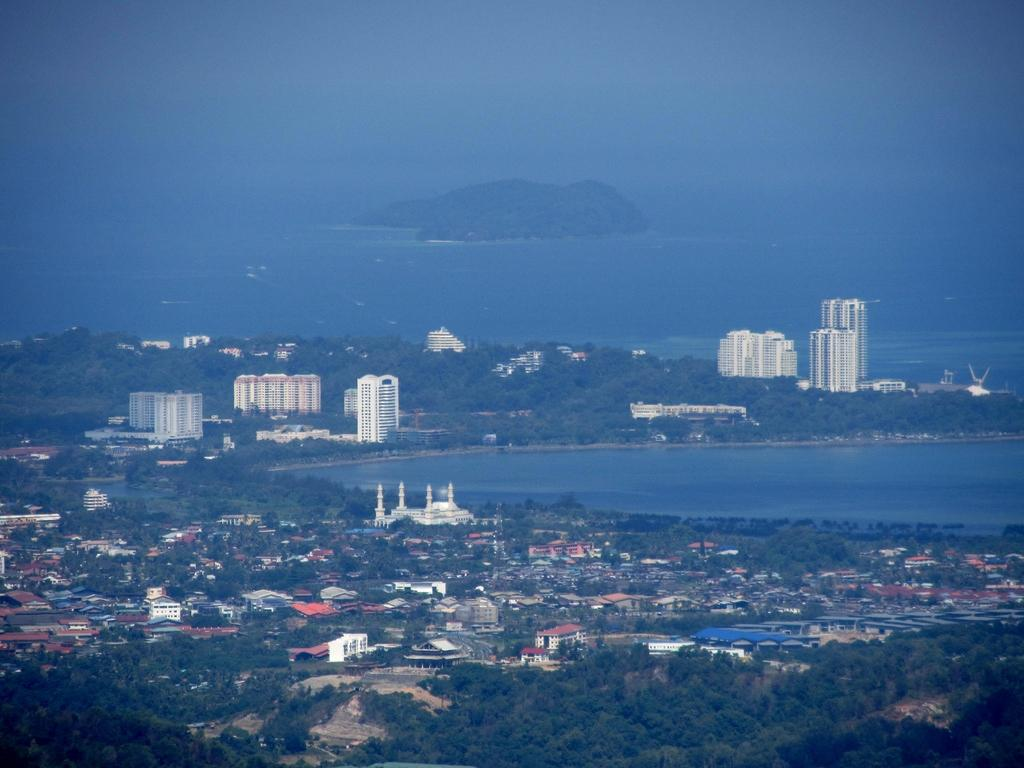What type of structures can be seen in the image? There are buildings in the image. What other natural elements are present in the image? There are trees and water visible in the image. What can be seen in the background of the image? The sky is visible in the background of the image. How many sheep are visible in the image? There are no sheep present in the image. What type of salt can be seen on the buildings in the image? There is no salt visible on the buildings in the image. 